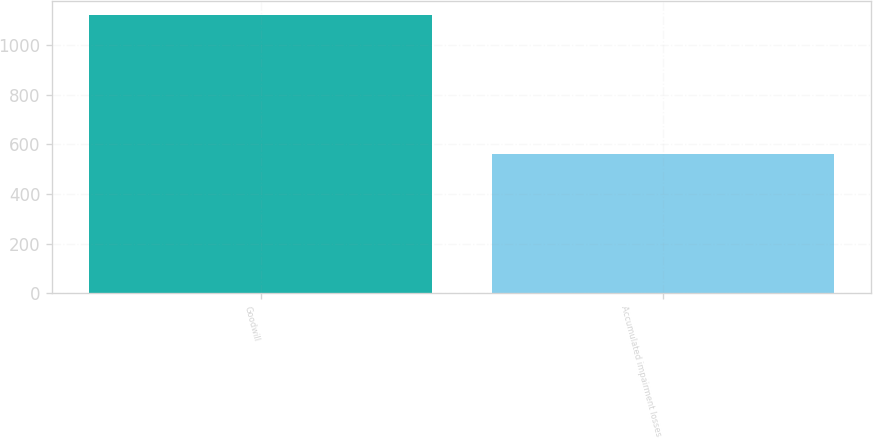<chart> <loc_0><loc_0><loc_500><loc_500><bar_chart><fcel>Goodwill<fcel>Accumulated impairment losses<nl><fcel>1123<fcel>560<nl></chart> 